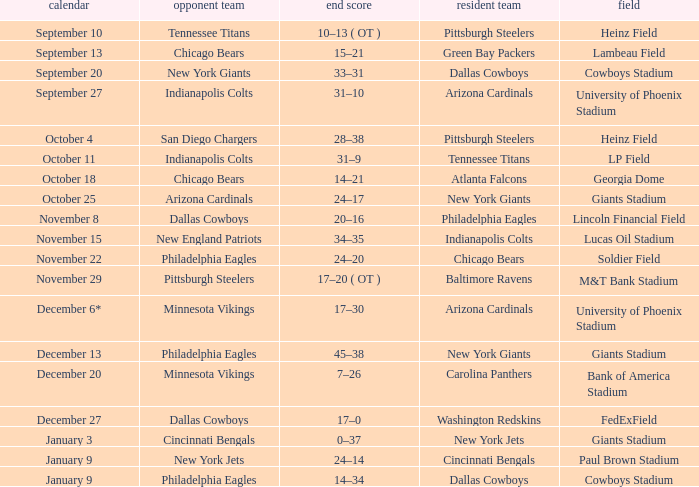Tell me the visiting team for october 4 San Diego Chargers. 